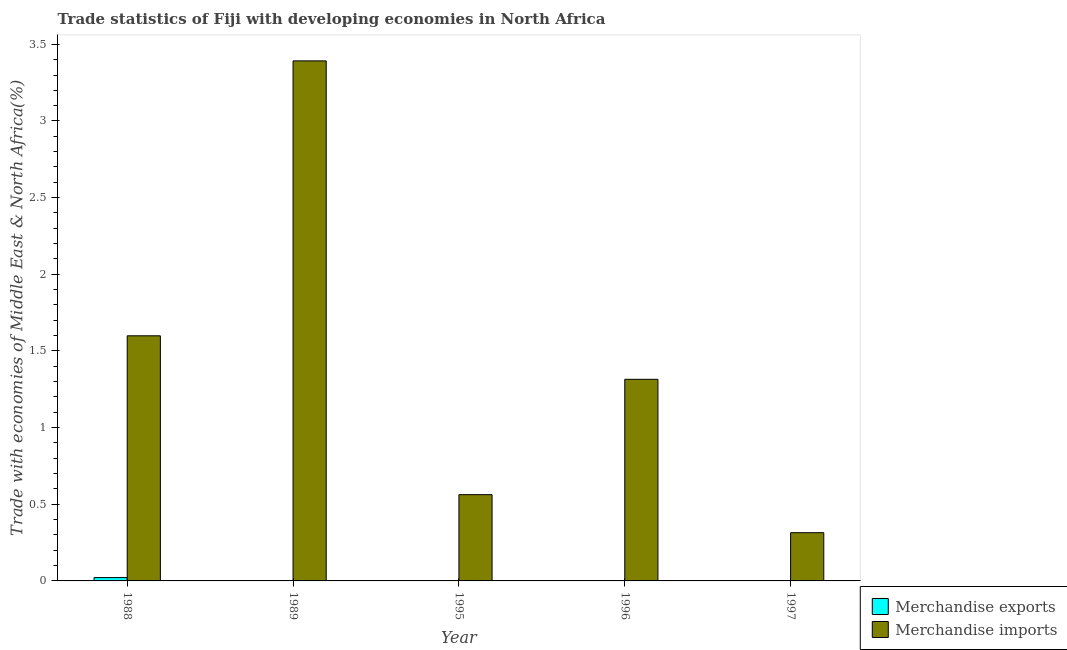How many different coloured bars are there?
Offer a very short reply. 2. How many groups of bars are there?
Make the answer very short. 5. Are the number of bars per tick equal to the number of legend labels?
Offer a terse response. Yes. Are the number of bars on each tick of the X-axis equal?
Give a very brief answer. Yes. How many bars are there on the 3rd tick from the left?
Your response must be concise. 2. How many bars are there on the 1st tick from the right?
Provide a succinct answer. 2. What is the label of the 4th group of bars from the left?
Offer a very short reply. 1996. In how many cases, is the number of bars for a given year not equal to the number of legend labels?
Offer a terse response. 0. What is the merchandise exports in 1989?
Your answer should be compact. 0. Across all years, what is the maximum merchandise imports?
Offer a terse response. 3.39. Across all years, what is the minimum merchandise exports?
Provide a succinct answer. 0. What is the total merchandise exports in the graph?
Keep it short and to the point. 0.03. What is the difference between the merchandise exports in 1988 and that in 1989?
Keep it short and to the point. 0.02. What is the difference between the merchandise imports in 1996 and the merchandise exports in 1995?
Your answer should be very brief. 0.75. What is the average merchandise imports per year?
Provide a succinct answer. 1.44. In the year 1995, what is the difference between the merchandise imports and merchandise exports?
Provide a short and direct response. 0. What is the ratio of the merchandise imports in 1988 to that in 1995?
Offer a terse response. 2.84. Is the merchandise exports in 1988 less than that in 1997?
Make the answer very short. No. Is the difference between the merchandise exports in 1995 and 1997 greater than the difference between the merchandise imports in 1995 and 1997?
Offer a very short reply. No. What is the difference between the highest and the second highest merchandise imports?
Keep it short and to the point. 1.79. What is the difference between the highest and the lowest merchandise imports?
Provide a succinct answer. 3.08. In how many years, is the merchandise imports greater than the average merchandise imports taken over all years?
Provide a succinct answer. 2. Is the sum of the merchandise exports in 1995 and 1996 greater than the maximum merchandise imports across all years?
Offer a very short reply. No. What does the 2nd bar from the left in 1988 represents?
Your answer should be very brief. Merchandise imports. How many bars are there?
Ensure brevity in your answer.  10. How many years are there in the graph?
Ensure brevity in your answer.  5. What is the difference between two consecutive major ticks on the Y-axis?
Your answer should be compact. 0.5. Are the values on the major ticks of Y-axis written in scientific E-notation?
Make the answer very short. No. Does the graph contain grids?
Ensure brevity in your answer.  No. How are the legend labels stacked?
Offer a terse response. Vertical. What is the title of the graph?
Your answer should be compact. Trade statistics of Fiji with developing economies in North Africa. What is the label or title of the X-axis?
Your answer should be very brief. Year. What is the label or title of the Y-axis?
Your answer should be very brief. Trade with economies of Middle East & North Africa(%). What is the Trade with economies of Middle East & North Africa(%) of Merchandise exports in 1988?
Your answer should be very brief. 0.02. What is the Trade with economies of Middle East & North Africa(%) of Merchandise imports in 1988?
Provide a succinct answer. 1.6. What is the Trade with economies of Middle East & North Africa(%) of Merchandise exports in 1989?
Your answer should be very brief. 0. What is the Trade with economies of Middle East & North Africa(%) of Merchandise imports in 1989?
Give a very brief answer. 3.39. What is the Trade with economies of Middle East & North Africa(%) in Merchandise exports in 1995?
Your answer should be compact. 0. What is the Trade with economies of Middle East & North Africa(%) in Merchandise imports in 1995?
Keep it short and to the point. 0.56. What is the Trade with economies of Middle East & North Africa(%) of Merchandise exports in 1996?
Give a very brief answer. 0. What is the Trade with economies of Middle East & North Africa(%) in Merchandise imports in 1996?
Ensure brevity in your answer.  1.31. What is the Trade with economies of Middle East & North Africa(%) of Merchandise exports in 1997?
Your answer should be compact. 0. What is the Trade with economies of Middle East & North Africa(%) of Merchandise imports in 1997?
Offer a terse response. 0.31. Across all years, what is the maximum Trade with economies of Middle East & North Africa(%) in Merchandise exports?
Offer a very short reply. 0.02. Across all years, what is the maximum Trade with economies of Middle East & North Africa(%) of Merchandise imports?
Your answer should be very brief. 3.39. Across all years, what is the minimum Trade with economies of Middle East & North Africa(%) in Merchandise exports?
Your response must be concise. 0. Across all years, what is the minimum Trade with economies of Middle East & North Africa(%) in Merchandise imports?
Offer a very short reply. 0.31. What is the total Trade with economies of Middle East & North Africa(%) in Merchandise exports in the graph?
Offer a very short reply. 0.03. What is the total Trade with economies of Middle East & North Africa(%) in Merchandise imports in the graph?
Keep it short and to the point. 7.18. What is the difference between the Trade with economies of Middle East & North Africa(%) in Merchandise exports in 1988 and that in 1989?
Your answer should be very brief. 0.02. What is the difference between the Trade with economies of Middle East & North Africa(%) in Merchandise imports in 1988 and that in 1989?
Give a very brief answer. -1.79. What is the difference between the Trade with economies of Middle East & North Africa(%) in Merchandise exports in 1988 and that in 1995?
Your response must be concise. 0.02. What is the difference between the Trade with economies of Middle East & North Africa(%) of Merchandise imports in 1988 and that in 1995?
Offer a terse response. 1.04. What is the difference between the Trade with economies of Middle East & North Africa(%) in Merchandise exports in 1988 and that in 1996?
Offer a very short reply. 0.02. What is the difference between the Trade with economies of Middle East & North Africa(%) of Merchandise imports in 1988 and that in 1996?
Your answer should be compact. 0.28. What is the difference between the Trade with economies of Middle East & North Africa(%) in Merchandise exports in 1988 and that in 1997?
Keep it short and to the point. 0.02. What is the difference between the Trade with economies of Middle East & North Africa(%) of Merchandise imports in 1988 and that in 1997?
Offer a very short reply. 1.28. What is the difference between the Trade with economies of Middle East & North Africa(%) of Merchandise exports in 1989 and that in 1995?
Offer a very short reply. 0. What is the difference between the Trade with economies of Middle East & North Africa(%) of Merchandise imports in 1989 and that in 1995?
Give a very brief answer. 2.83. What is the difference between the Trade with economies of Middle East & North Africa(%) in Merchandise exports in 1989 and that in 1996?
Your answer should be compact. -0. What is the difference between the Trade with economies of Middle East & North Africa(%) in Merchandise imports in 1989 and that in 1996?
Make the answer very short. 2.08. What is the difference between the Trade with economies of Middle East & North Africa(%) of Merchandise exports in 1989 and that in 1997?
Ensure brevity in your answer.  0. What is the difference between the Trade with economies of Middle East & North Africa(%) in Merchandise imports in 1989 and that in 1997?
Offer a very short reply. 3.08. What is the difference between the Trade with economies of Middle East & North Africa(%) of Merchandise exports in 1995 and that in 1996?
Offer a terse response. -0. What is the difference between the Trade with economies of Middle East & North Africa(%) in Merchandise imports in 1995 and that in 1996?
Offer a terse response. -0.75. What is the difference between the Trade with economies of Middle East & North Africa(%) of Merchandise exports in 1995 and that in 1997?
Provide a short and direct response. 0. What is the difference between the Trade with economies of Middle East & North Africa(%) in Merchandise imports in 1995 and that in 1997?
Make the answer very short. 0.25. What is the difference between the Trade with economies of Middle East & North Africa(%) in Merchandise exports in 1996 and that in 1997?
Your response must be concise. 0. What is the difference between the Trade with economies of Middle East & North Africa(%) of Merchandise imports in 1996 and that in 1997?
Make the answer very short. 1. What is the difference between the Trade with economies of Middle East & North Africa(%) in Merchandise exports in 1988 and the Trade with economies of Middle East & North Africa(%) in Merchandise imports in 1989?
Keep it short and to the point. -3.37. What is the difference between the Trade with economies of Middle East & North Africa(%) in Merchandise exports in 1988 and the Trade with economies of Middle East & North Africa(%) in Merchandise imports in 1995?
Ensure brevity in your answer.  -0.54. What is the difference between the Trade with economies of Middle East & North Africa(%) of Merchandise exports in 1988 and the Trade with economies of Middle East & North Africa(%) of Merchandise imports in 1996?
Offer a terse response. -1.29. What is the difference between the Trade with economies of Middle East & North Africa(%) in Merchandise exports in 1988 and the Trade with economies of Middle East & North Africa(%) in Merchandise imports in 1997?
Your response must be concise. -0.29. What is the difference between the Trade with economies of Middle East & North Africa(%) in Merchandise exports in 1989 and the Trade with economies of Middle East & North Africa(%) in Merchandise imports in 1995?
Keep it short and to the point. -0.56. What is the difference between the Trade with economies of Middle East & North Africa(%) of Merchandise exports in 1989 and the Trade with economies of Middle East & North Africa(%) of Merchandise imports in 1996?
Give a very brief answer. -1.31. What is the difference between the Trade with economies of Middle East & North Africa(%) in Merchandise exports in 1989 and the Trade with economies of Middle East & North Africa(%) in Merchandise imports in 1997?
Offer a terse response. -0.31. What is the difference between the Trade with economies of Middle East & North Africa(%) of Merchandise exports in 1995 and the Trade with economies of Middle East & North Africa(%) of Merchandise imports in 1996?
Ensure brevity in your answer.  -1.31. What is the difference between the Trade with economies of Middle East & North Africa(%) of Merchandise exports in 1995 and the Trade with economies of Middle East & North Africa(%) of Merchandise imports in 1997?
Offer a very short reply. -0.31. What is the difference between the Trade with economies of Middle East & North Africa(%) of Merchandise exports in 1996 and the Trade with economies of Middle East & North Africa(%) of Merchandise imports in 1997?
Provide a succinct answer. -0.31. What is the average Trade with economies of Middle East & North Africa(%) of Merchandise exports per year?
Offer a very short reply. 0.01. What is the average Trade with economies of Middle East & North Africa(%) of Merchandise imports per year?
Provide a succinct answer. 1.44. In the year 1988, what is the difference between the Trade with economies of Middle East & North Africa(%) in Merchandise exports and Trade with economies of Middle East & North Africa(%) in Merchandise imports?
Make the answer very short. -1.58. In the year 1989, what is the difference between the Trade with economies of Middle East & North Africa(%) of Merchandise exports and Trade with economies of Middle East & North Africa(%) of Merchandise imports?
Make the answer very short. -3.39. In the year 1995, what is the difference between the Trade with economies of Middle East & North Africa(%) of Merchandise exports and Trade with economies of Middle East & North Africa(%) of Merchandise imports?
Make the answer very short. -0.56. In the year 1996, what is the difference between the Trade with economies of Middle East & North Africa(%) of Merchandise exports and Trade with economies of Middle East & North Africa(%) of Merchandise imports?
Keep it short and to the point. -1.31. In the year 1997, what is the difference between the Trade with economies of Middle East & North Africa(%) of Merchandise exports and Trade with economies of Middle East & North Africa(%) of Merchandise imports?
Keep it short and to the point. -0.31. What is the ratio of the Trade with economies of Middle East & North Africa(%) of Merchandise exports in 1988 to that in 1989?
Keep it short and to the point. 21.22. What is the ratio of the Trade with economies of Middle East & North Africa(%) of Merchandise imports in 1988 to that in 1989?
Provide a short and direct response. 0.47. What is the ratio of the Trade with economies of Middle East & North Africa(%) of Merchandise exports in 1988 to that in 1995?
Your response must be concise. 23.43. What is the ratio of the Trade with economies of Middle East & North Africa(%) in Merchandise imports in 1988 to that in 1995?
Make the answer very short. 2.84. What is the ratio of the Trade with economies of Middle East & North Africa(%) in Merchandise exports in 1988 to that in 1996?
Offer a terse response. 9.04. What is the ratio of the Trade with economies of Middle East & North Africa(%) in Merchandise imports in 1988 to that in 1996?
Provide a succinct answer. 1.22. What is the ratio of the Trade with economies of Middle East & North Africa(%) in Merchandise exports in 1988 to that in 1997?
Your answer should be compact. 197.63. What is the ratio of the Trade with economies of Middle East & North Africa(%) in Merchandise imports in 1988 to that in 1997?
Provide a short and direct response. 5.08. What is the ratio of the Trade with economies of Middle East & North Africa(%) in Merchandise exports in 1989 to that in 1995?
Offer a terse response. 1.1. What is the ratio of the Trade with economies of Middle East & North Africa(%) in Merchandise imports in 1989 to that in 1995?
Offer a terse response. 6.03. What is the ratio of the Trade with economies of Middle East & North Africa(%) in Merchandise exports in 1989 to that in 1996?
Your answer should be compact. 0.43. What is the ratio of the Trade with economies of Middle East & North Africa(%) of Merchandise imports in 1989 to that in 1996?
Your response must be concise. 2.58. What is the ratio of the Trade with economies of Middle East & North Africa(%) in Merchandise exports in 1989 to that in 1997?
Offer a very short reply. 9.31. What is the ratio of the Trade with economies of Middle East & North Africa(%) in Merchandise imports in 1989 to that in 1997?
Offer a terse response. 10.78. What is the ratio of the Trade with economies of Middle East & North Africa(%) of Merchandise exports in 1995 to that in 1996?
Offer a terse response. 0.39. What is the ratio of the Trade with economies of Middle East & North Africa(%) of Merchandise imports in 1995 to that in 1996?
Ensure brevity in your answer.  0.43. What is the ratio of the Trade with economies of Middle East & North Africa(%) of Merchandise exports in 1995 to that in 1997?
Give a very brief answer. 8.43. What is the ratio of the Trade with economies of Middle East & North Africa(%) in Merchandise imports in 1995 to that in 1997?
Offer a very short reply. 1.79. What is the ratio of the Trade with economies of Middle East & North Africa(%) in Merchandise exports in 1996 to that in 1997?
Offer a very short reply. 21.87. What is the ratio of the Trade with economies of Middle East & North Africa(%) in Merchandise imports in 1996 to that in 1997?
Your answer should be compact. 4.18. What is the difference between the highest and the second highest Trade with economies of Middle East & North Africa(%) in Merchandise exports?
Keep it short and to the point. 0.02. What is the difference between the highest and the second highest Trade with economies of Middle East & North Africa(%) in Merchandise imports?
Ensure brevity in your answer.  1.79. What is the difference between the highest and the lowest Trade with economies of Middle East & North Africa(%) of Merchandise exports?
Offer a terse response. 0.02. What is the difference between the highest and the lowest Trade with economies of Middle East & North Africa(%) of Merchandise imports?
Offer a terse response. 3.08. 